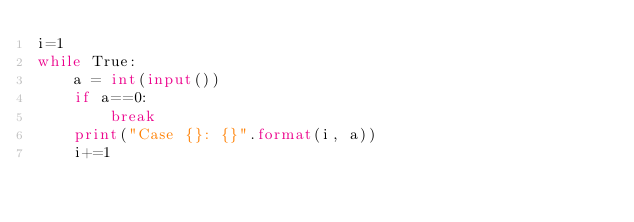Convert code to text. <code><loc_0><loc_0><loc_500><loc_500><_Python_>i=1
while True:
	a = int(input())
	if a==0:
		break
	print("Case {}: {}".format(i, a))
	i+=1


</code> 